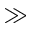Convert formula to latex. <formula><loc_0><loc_0><loc_500><loc_500>\gg</formula> 